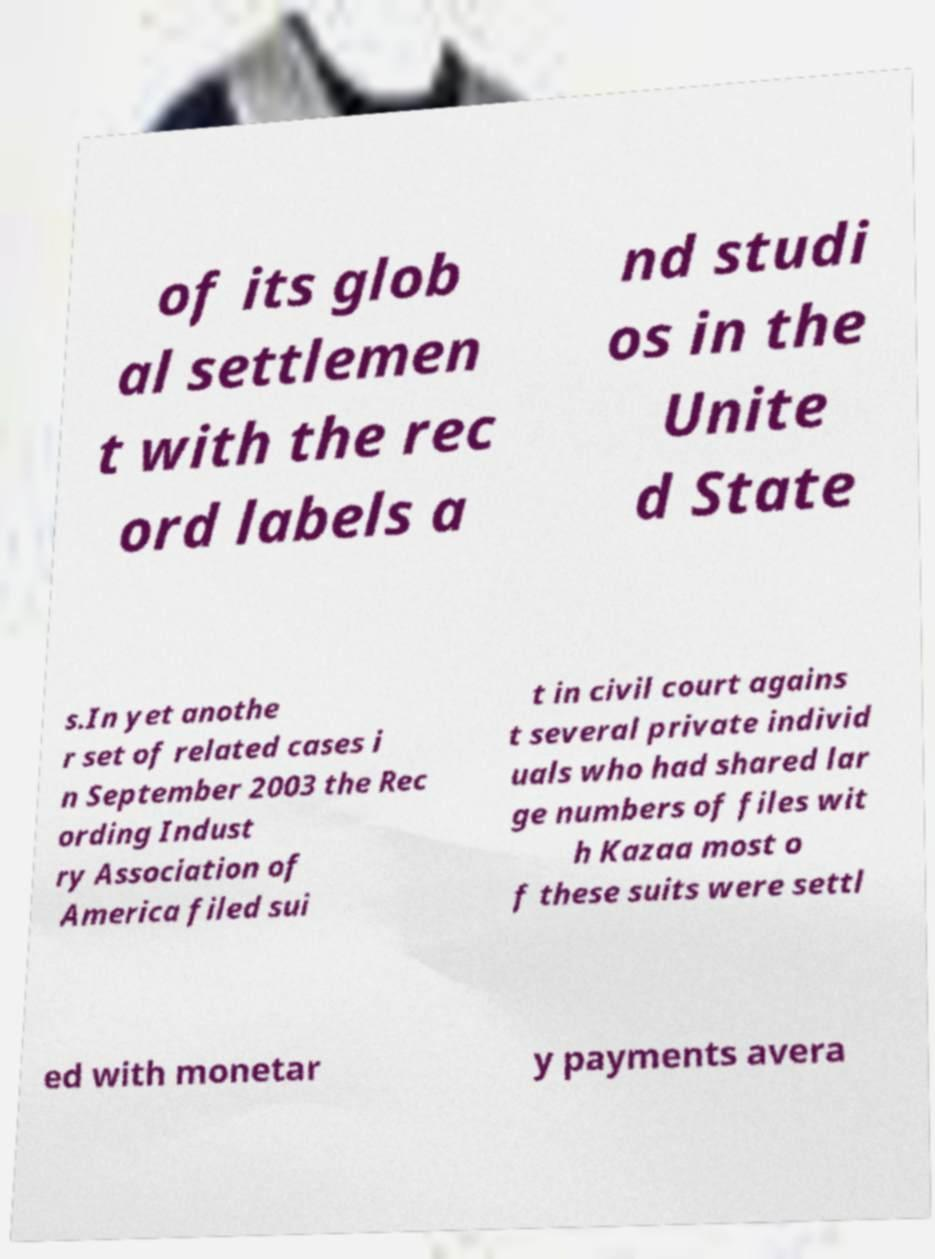There's text embedded in this image that I need extracted. Can you transcribe it verbatim? of its glob al settlemen t with the rec ord labels a nd studi os in the Unite d State s.In yet anothe r set of related cases i n September 2003 the Rec ording Indust ry Association of America filed sui t in civil court agains t several private individ uals who had shared lar ge numbers of files wit h Kazaa most o f these suits were settl ed with monetar y payments avera 